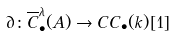<formula> <loc_0><loc_0><loc_500><loc_500>\partial \colon \overline { C } ^ { \lambda } _ { \bullet } ( A ) \to C C _ { \bullet } ( k ) [ 1 ]</formula> 